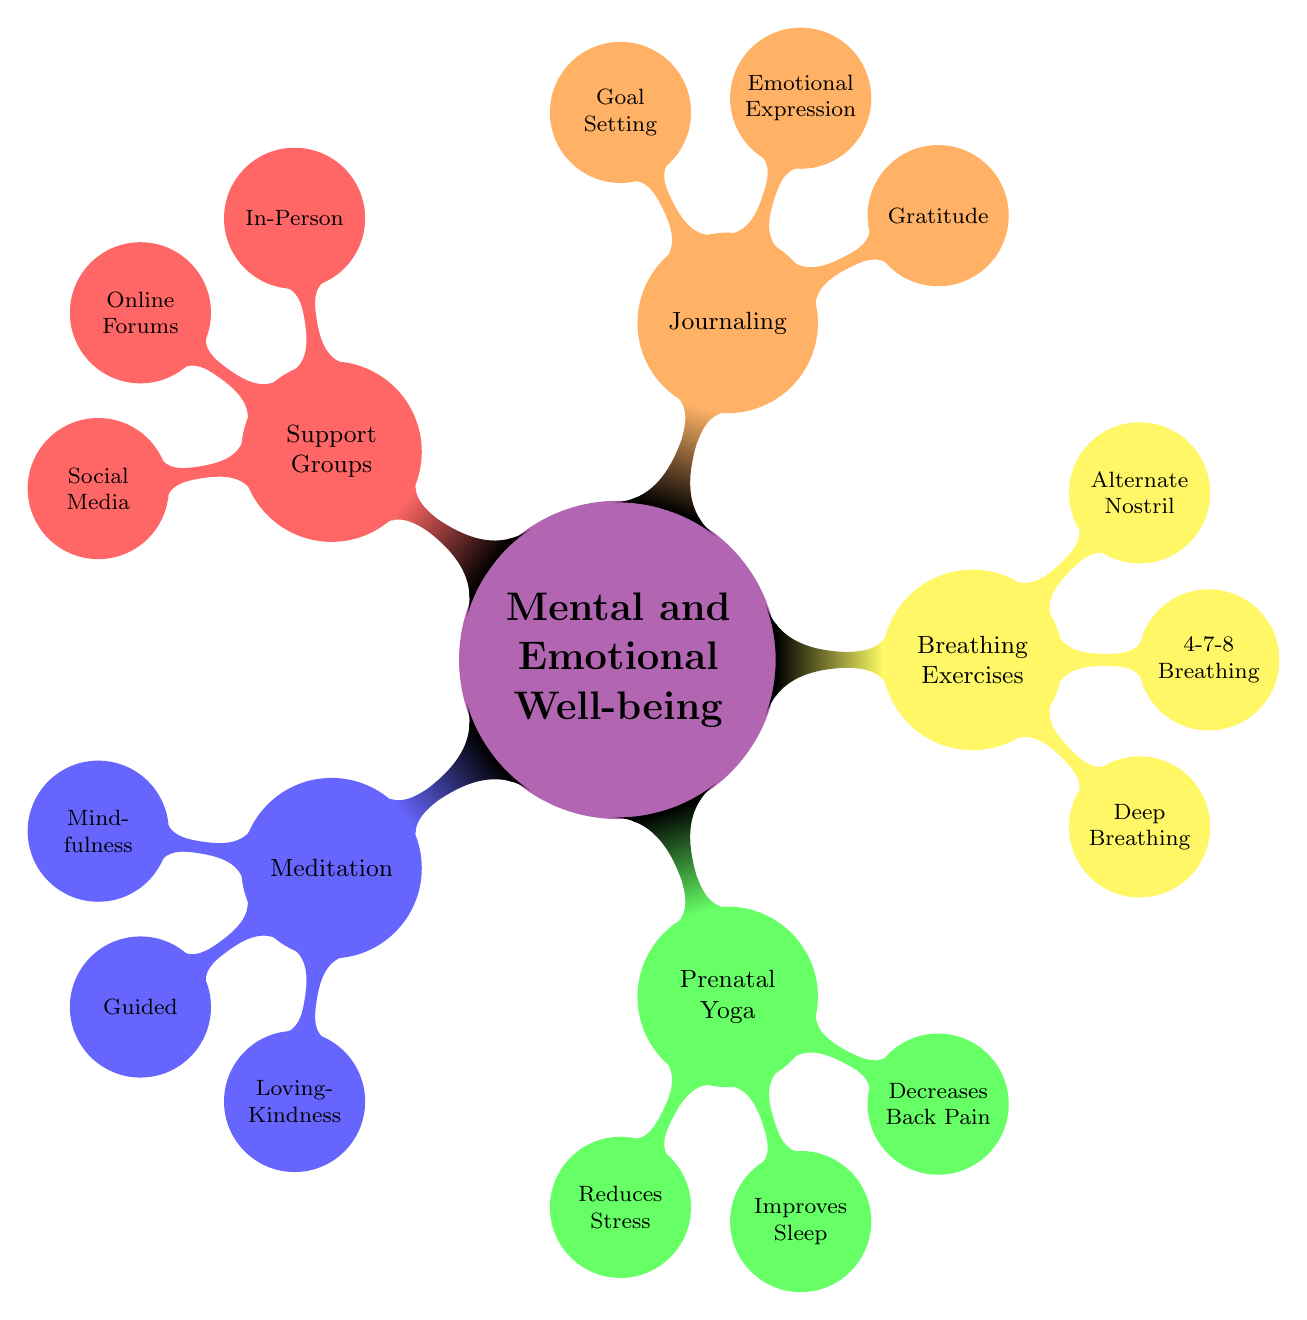What are the two main types of meditation listed? The diagram specifies three types of meditation under the "Meditation" node: Mindfulness Meditation, Guided Meditation, and Loving-Kindness Meditation. So, picking any two from these qualifies as an answer.
Answer: Mindfulness Meditation, Guided Meditation What benefits are associated with Prenatal Yoga? Under the "Prenatal Yoga" node, three specific benefits are listed: Reduces Stress, Improves Sleep, and Decreases Lower Back Pain. Therefore, these three benefits articulate the positive effects of practicing Prenatal Yoga.
Answer: Reduces Stress, Improves Sleep, Decreases Lower Back Pain How many breathing techniques are mentioned? The "Breathing Exercises" node includes three techniques: Deep Breathing, 4-7-8 Breathing, and Alternate Nostril Breathing. Counting them results in a total of three techniques shown in the diagram.
Answer: 3 What type of journaling focuses on positive aspects? The diagram lists types of journaling under the "Journaling" node, which includes Gratitude Journaling, Emotional Expression, and Goal Setting. Gratitude Journaling specifically focuses on positive aspects of life during pregnancy.
Answer: Gratitude Journaling Which support group type is found both in-person and online? The "Support Groups" node mentions three types: In-Person Groups, Online Forums, and Social Media Groups. In-Person Groups and Online Forums represent the answer as they cover both formats of interaction.
Answer: In-Person Groups, Online Forums What emotional practice helps reduce stress and improve sleep? The "Prenatal Yoga" node identifies two specific benefits: Reduces Stress and Improves Sleep, which highlights its effectiveness as an emotional practice beneficial during pregnancy.
Answer: Prenatal Yoga 